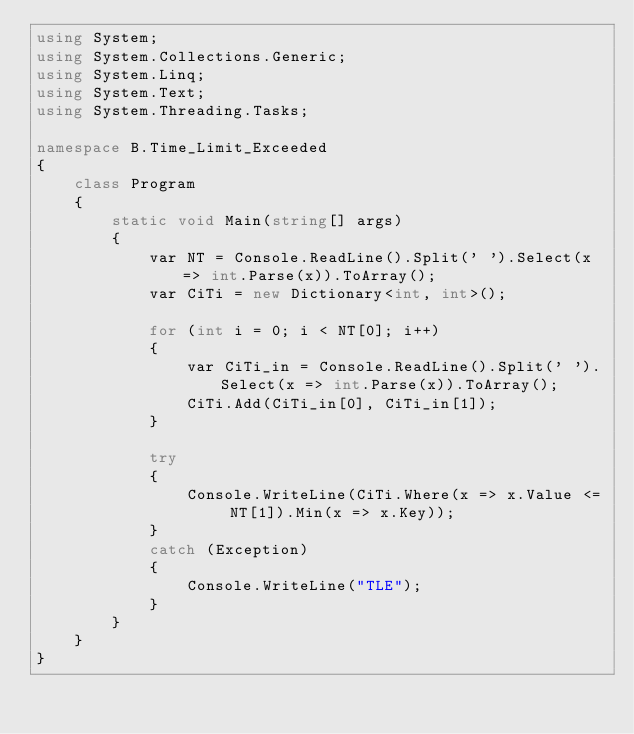Convert code to text. <code><loc_0><loc_0><loc_500><loc_500><_C#_>using System;
using System.Collections.Generic;
using System.Linq;
using System.Text;
using System.Threading.Tasks;

namespace B.Time_Limit_Exceeded
{
    class Program
    {
        static void Main(string[] args)
        {
            var NT = Console.ReadLine().Split(' ').Select(x => int.Parse(x)).ToArray();
            var CiTi = new Dictionary<int, int>();

            for (int i = 0; i < NT[0]; i++)
            {
                var CiTi_in = Console.ReadLine().Split(' ').Select(x => int.Parse(x)).ToArray();
                CiTi.Add(CiTi_in[0], CiTi_in[1]);
            }
    
            try
            {
                Console.WriteLine(CiTi.Where(x => x.Value <= NT[1]).Min(x => x.Key));
            }
            catch (Exception)
            {
                Console.WriteLine("TLE");
            }
        }
    }
}</code> 